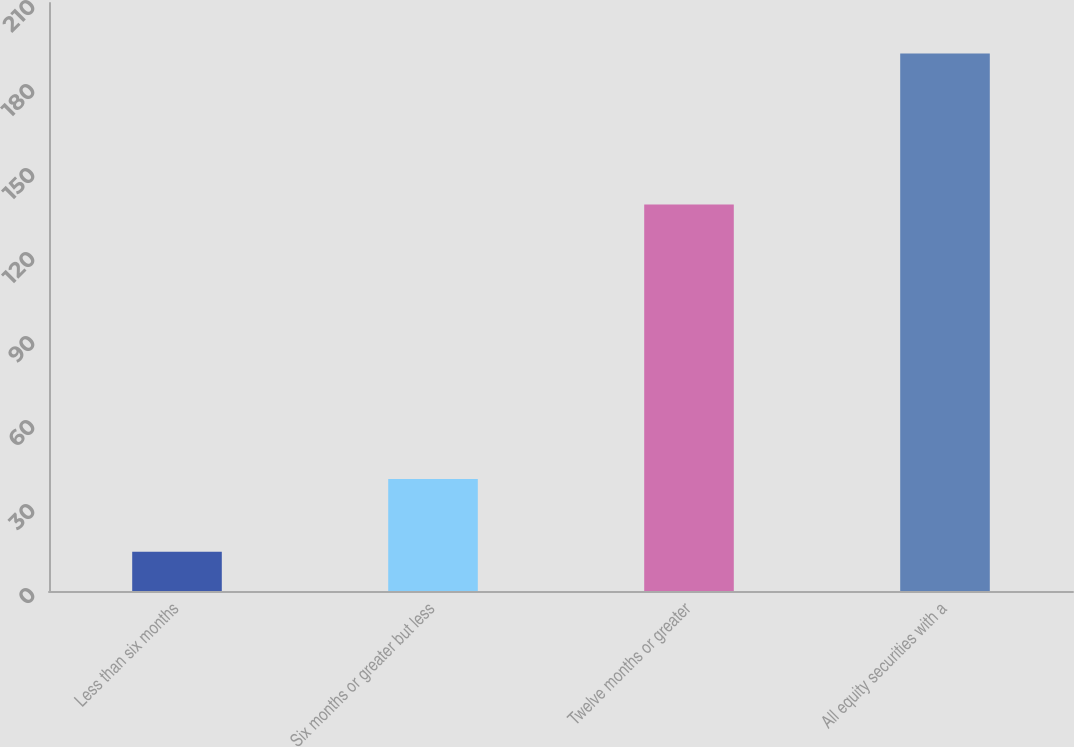<chart> <loc_0><loc_0><loc_500><loc_500><bar_chart><fcel>Less than six months<fcel>Six months or greater but less<fcel>Twelve months or greater<fcel>All equity securities with a<nl><fcel>14<fcel>40<fcel>138<fcel>192<nl></chart> 